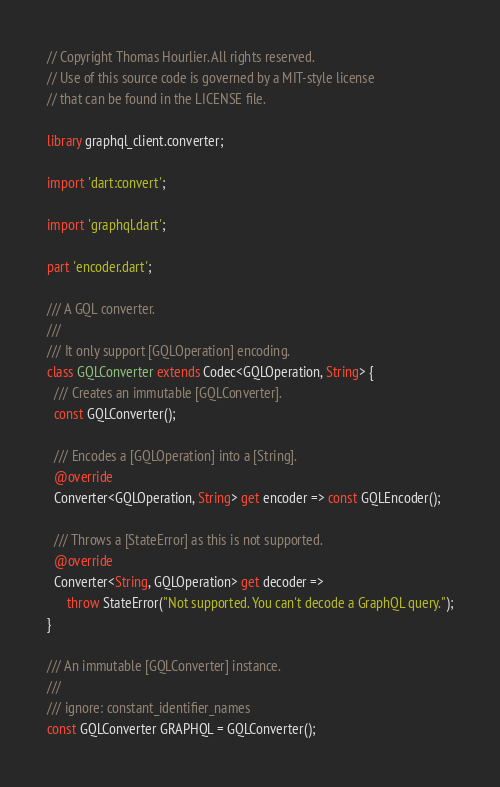<code> <loc_0><loc_0><loc_500><loc_500><_Dart_>// Copyright Thomas Hourlier. All rights reserved.
// Use of this source code is governed by a MIT-style license
// that can be found in the LICENSE file.

library graphql_client.converter;

import 'dart:convert';

import 'graphql.dart';

part 'encoder.dart';

/// A GQL converter.
///
/// It only support [GQLOperation] encoding.
class GQLConverter extends Codec<GQLOperation, String> {
  /// Creates an immutable [GQLConverter].
  const GQLConverter();

  /// Encodes a [GQLOperation] into a [String].
  @override
  Converter<GQLOperation, String> get encoder => const GQLEncoder();

  /// Throws a [StateError] as this is not supported.
  @override
  Converter<String, GQLOperation> get decoder =>
      throw StateError("Not supported. You can't decode a GraphQL query.");
}

/// An immutable [GQLConverter] instance.
///
/// ignore: constant_identifier_names
const GQLConverter GRAPHQL = GQLConverter();
</code> 